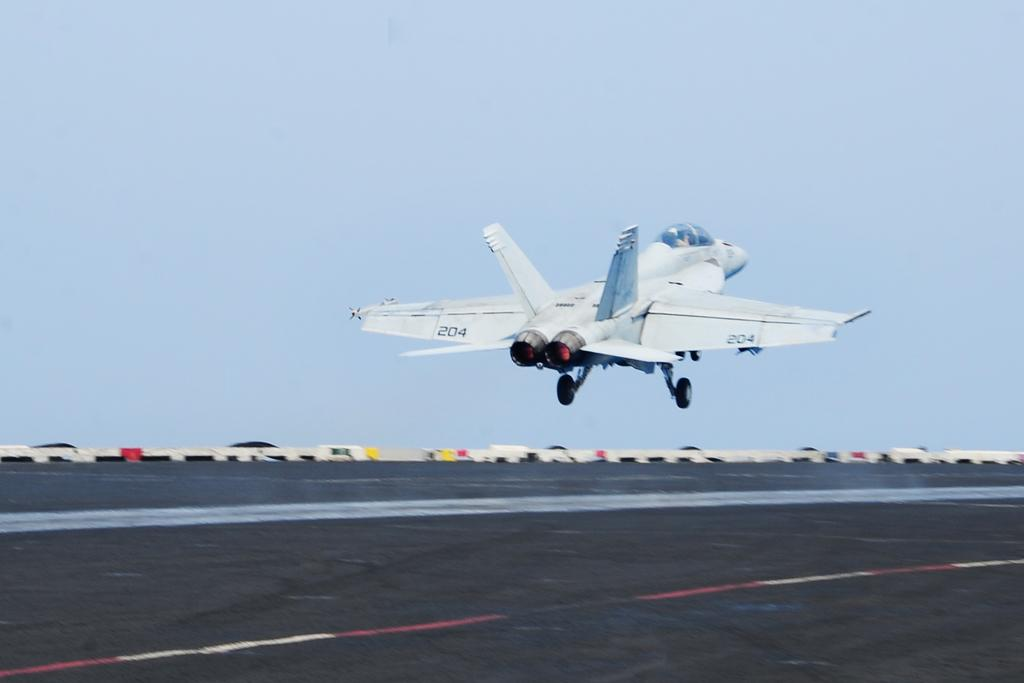What is the main subject of the image? The main subject of the image is an aircraft. What is the aircraft doing in the image? The aircraft is flying above a runway. What can be seen in the background of the image? The sky is visible behind the aircraft. What type of rock is being used as a watch in the image? There is no rock or watch present in the image; it only features an aircraft flying above a runway with the sky visible in the background. 